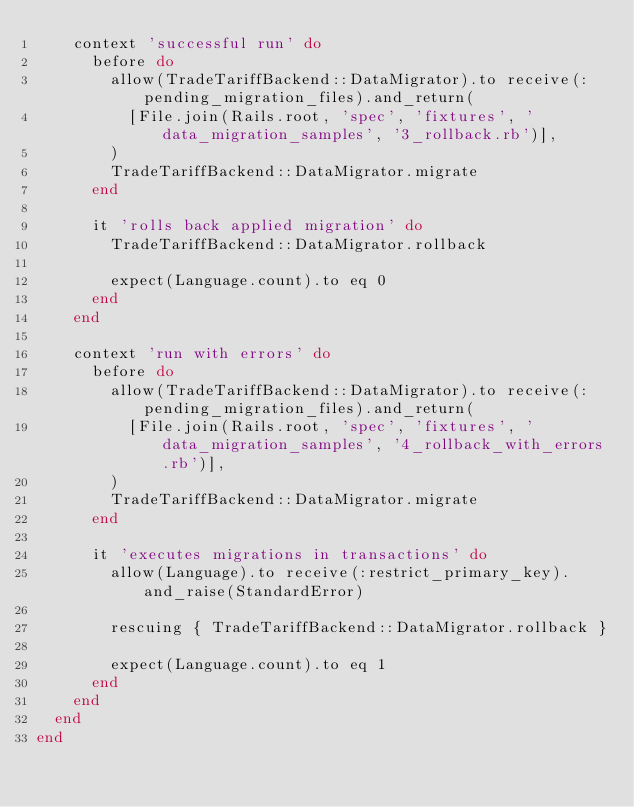Convert code to text. <code><loc_0><loc_0><loc_500><loc_500><_Ruby_>    context 'successful run' do
      before do
        allow(TradeTariffBackend::DataMigrator).to receive(:pending_migration_files).and_return(
          [File.join(Rails.root, 'spec', 'fixtures', 'data_migration_samples', '3_rollback.rb')],
        )
        TradeTariffBackend::DataMigrator.migrate
      end

      it 'rolls back applied migration' do
        TradeTariffBackend::DataMigrator.rollback

        expect(Language.count).to eq 0
      end
    end

    context 'run with errors' do
      before do
        allow(TradeTariffBackend::DataMigrator).to receive(:pending_migration_files).and_return(
          [File.join(Rails.root, 'spec', 'fixtures', 'data_migration_samples', '4_rollback_with_errors.rb')],
        )
        TradeTariffBackend::DataMigrator.migrate
      end

      it 'executes migrations in transactions' do
        allow(Language).to receive(:restrict_primary_key).and_raise(StandardError)

        rescuing { TradeTariffBackend::DataMigrator.rollback }

        expect(Language.count).to eq 1
      end
    end
  end
end
</code> 